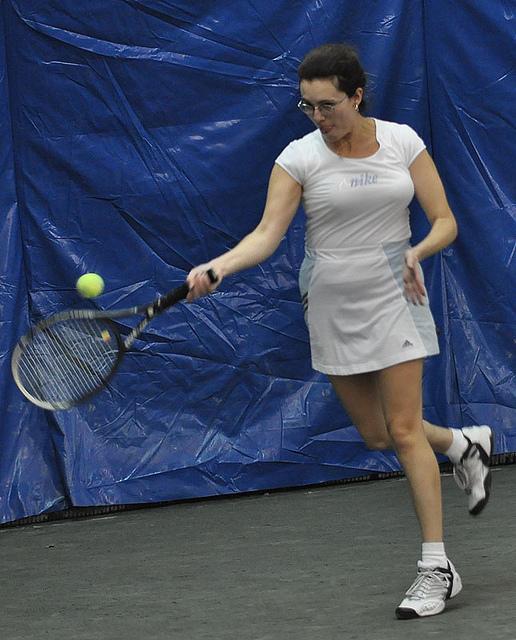What color is the screen behind her?
Be succinct. Blue. Are her clothes colorful?
Quick response, please. No. Are her shirt and skirt the same brand?
Concise answer only. No. Is the woman attempting to hit a little bomb?
Concise answer only. No. 